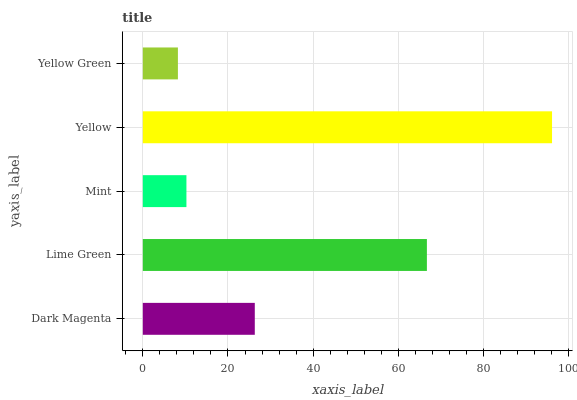Is Yellow Green the minimum?
Answer yes or no. Yes. Is Yellow the maximum?
Answer yes or no. Yes. Is Lime Green the minimum?
Answer yes or no. No. Is Lime Green the maximum?
Answer yes or no. No. Is Lime Green greater than Dark Magenta?
Answer yes or no. Yes. Is Dark Magenta less than Lime Green?
Answer yes or no. Yes. Is Dark Magenta greater than Lime Green?
Answer yes or no. No. Is Lime Green less than Dark Magenta?
Answer yes or no. No. Is Dark Magenta the high median?
Answer yes or no. Yes. Is Dark Magenta the low median?
Answer yes or no. Yes. Is Yellow the high median?
Answer yes or no. No. Is Mint the low median?
Answer yes or no. No. 